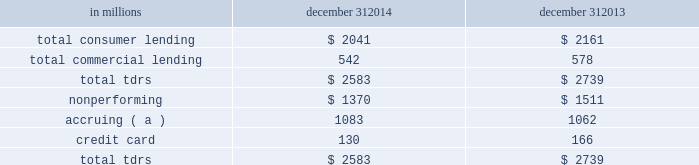Troubled debt restructurings ( tdrs ) a tdr is a loan whose terms have been restructured in a manner that grants a concession to a borrower experiencing financial difficulty .
Tdrs result from our loss mitigation activities , and include rate reductions , principal forgiveness , postponement/reduction of scheduled amortization , and extensions , which are intended to minimize economic loss and to avoid foreclosure or repossession of collateral .
Additionally , tdrs also result from borrowers that have been discharged from personal liability through chapter 7 bankruptcy and have not formally reaffirmed their loan obligations to pnc .
In those situations where principal is forgiven , the amount of such principal forgiveness is immediately charged off .
Some tdrs may not ultimately result in the full collection of principal and interest , as restructured , and result in potential incremental losses .
These potential incremental losses have been factored into our overall alll estimate .
The level of any subsequent defaults will likely be affected by future economic conditions .
Once a loan becomes a tdr , it will continue to be reported as a tdr until it is ultimately repaid in full , the collateral is foreclosed upon , or it is fully charged off .
We held specific reserves in the alll of $ .4 billion and $ .5 billion at december 31 , 2014 and december 31 , 2013 , respectively , for the total tdr portfolio .
Table 67 : summary of troubled debt restructurings in millions december 31 december 31 .
( a ) accruing tdr loans have demonstrated a period of at least six months of performance under the restructured terms and are excluded from nonperforming loans .
Loans where borrowers have been discharged from personal liability through chapter 7 bankruptcy and have not formally reaffirmed their loan obligations to pnc and loans to borrowers not currently obligated to make both principal and interest payments under the restructured terms are not returned to accrual status .
Table 68 quantifies the number of loans that were classified as tdrs as well as the change in the recorded investments as a result of the tdr classification during 2014 , 2013 , and 2012 , respectively .
Additionally , the table provides information about the types of tdr concessions .
The principal forgiveness tdr category includes principal forgiveness and accrued interest forgiveness .
These types of tdrs result in a write down of the recorded investment and a charge-off if such action has not already taken place .
The rate reduction tdr category includes reduced interest rate and interest deferral .
The tdrs within this category result in reductions to future interest income .
The other tdr category primarily includes consumer borrowers that have been discharged from personal liability through chapter 7 bankruptcy and have not formally reaffirmed their loan obligations to pnc , as well as postponement/reduction of scheduled amortization and contractual extensions for both consumer and commercial borrowers .
In some cases , there have been multiple concessions granted on one loan .
This is most common within the commercial loan portfolio .
When there have been multiple concessions granted in the commercial loan portfolio , the principal forgiveness concession was prioritized for purposes of determining the inclusion in table 68 .
For example , if there is principal forgiveness in conjunction with lower interest rate and postponement of amortization , the type of concession will be reported as principal forgiveness .
Second in priority would be rate reduction .
For example , if there is an interest rate reduction in conjunction with postponement of amortization , the type of concession will be reported as a rate reduction .
In the event that multiple concessions are granted on a consumer loan , concessions resulting from discharge from personal liability through chapter 7 bankruptcy without formal affirmation of the loan obligations to pnc would be prioritized and included in the other type of concession in the table below .
After that , consumer loan concessions would follow the previously discussed priority of concessions for the commercial loan portfolio .
138 the pnc financial services group , inc .
2013 form 10-k .
What were average specific reserves in the alll in billions at december 31 , 2014 and december 31 , 2013 for the total tdr portfolio? 
Computations: ((.5 + .4) / 2)
Answer: 0.45. 